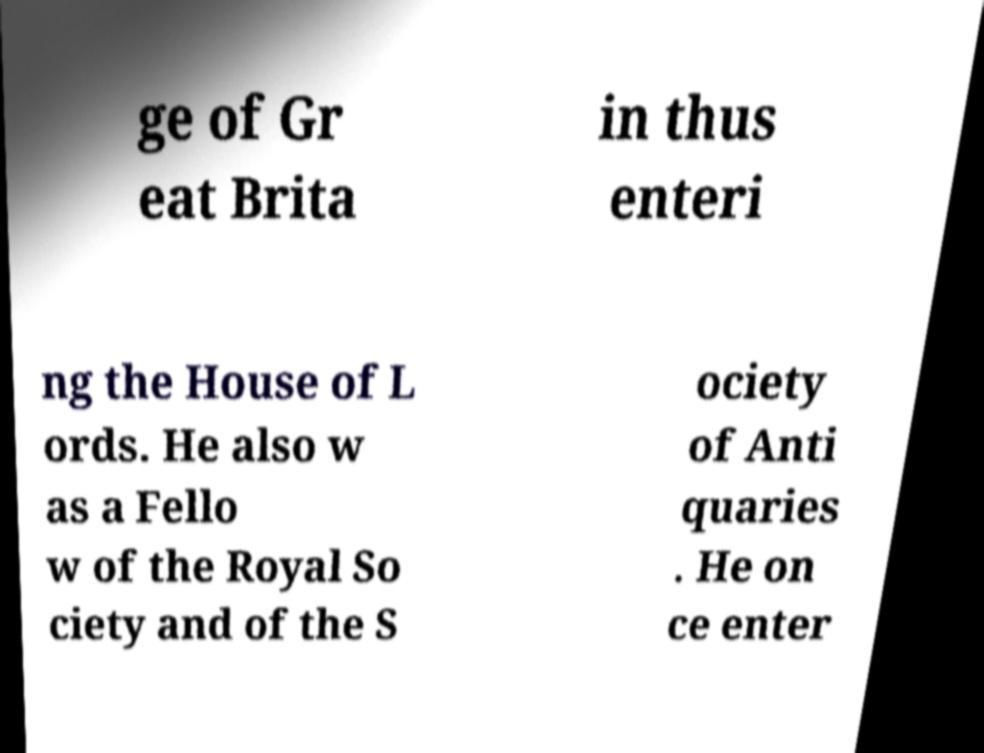Could you extract and type out the text from this image? ge of Gr eat Brita in thus enteri ng the House of L ords. He also w as a Fello w of the Royal So ciety and of the S ociety of Anti quaries . He on ce enter 